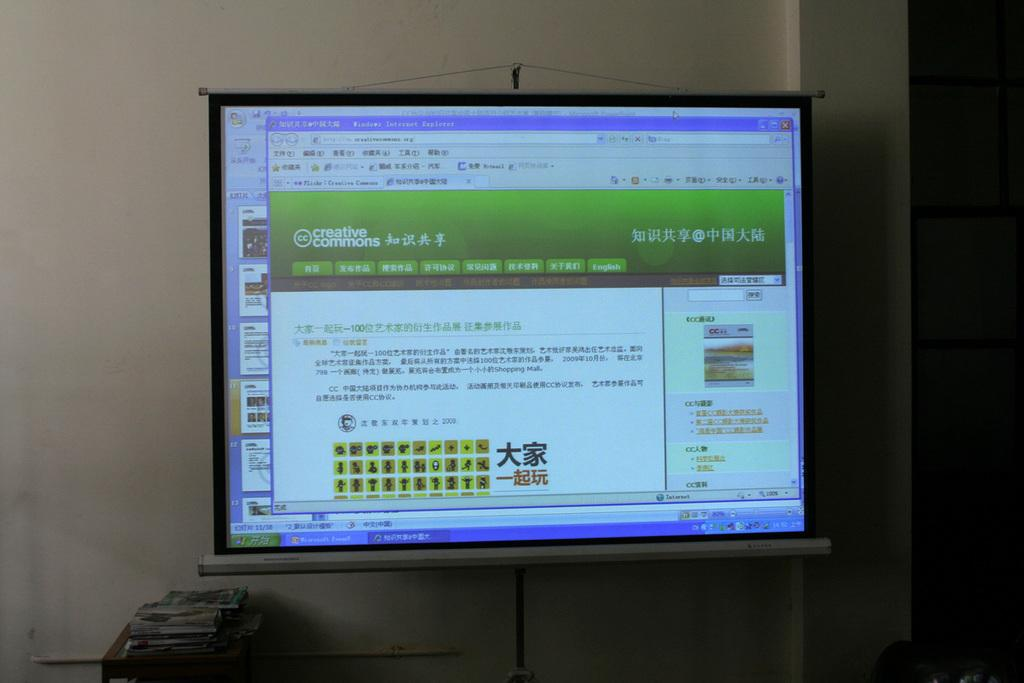<image>
Render a clear and concise summary of the photo. Creative Commons web page, not translated, pulled up on a computer monitor. 